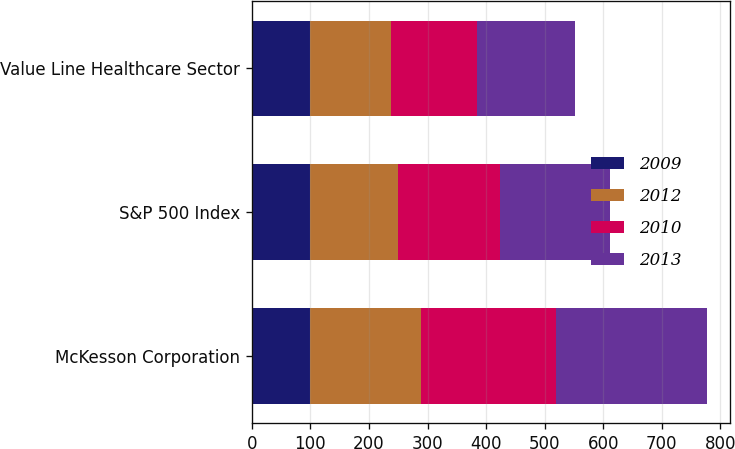Convert chart to OTSL. <chart><loc_0><loc_0><loc_500><loc_500><stacked_bar_chart><ecel><fcel>McKesson Corporation<fcel>S&P 500 Index<fcel>Value Line Healthcare Sector<nl><fcel>2009<fcel>100<fcel>100<fcel>100<nl><fcel>2012<fcel>189.25<fcel>149.77<fcel>137.73<nl><fcel>2010<fcel>230.09<fcel>173.21<fcel>147.44<nl><fcel>2013<fcel>258<fcel>188<fcel>167.52<nl></chart> 